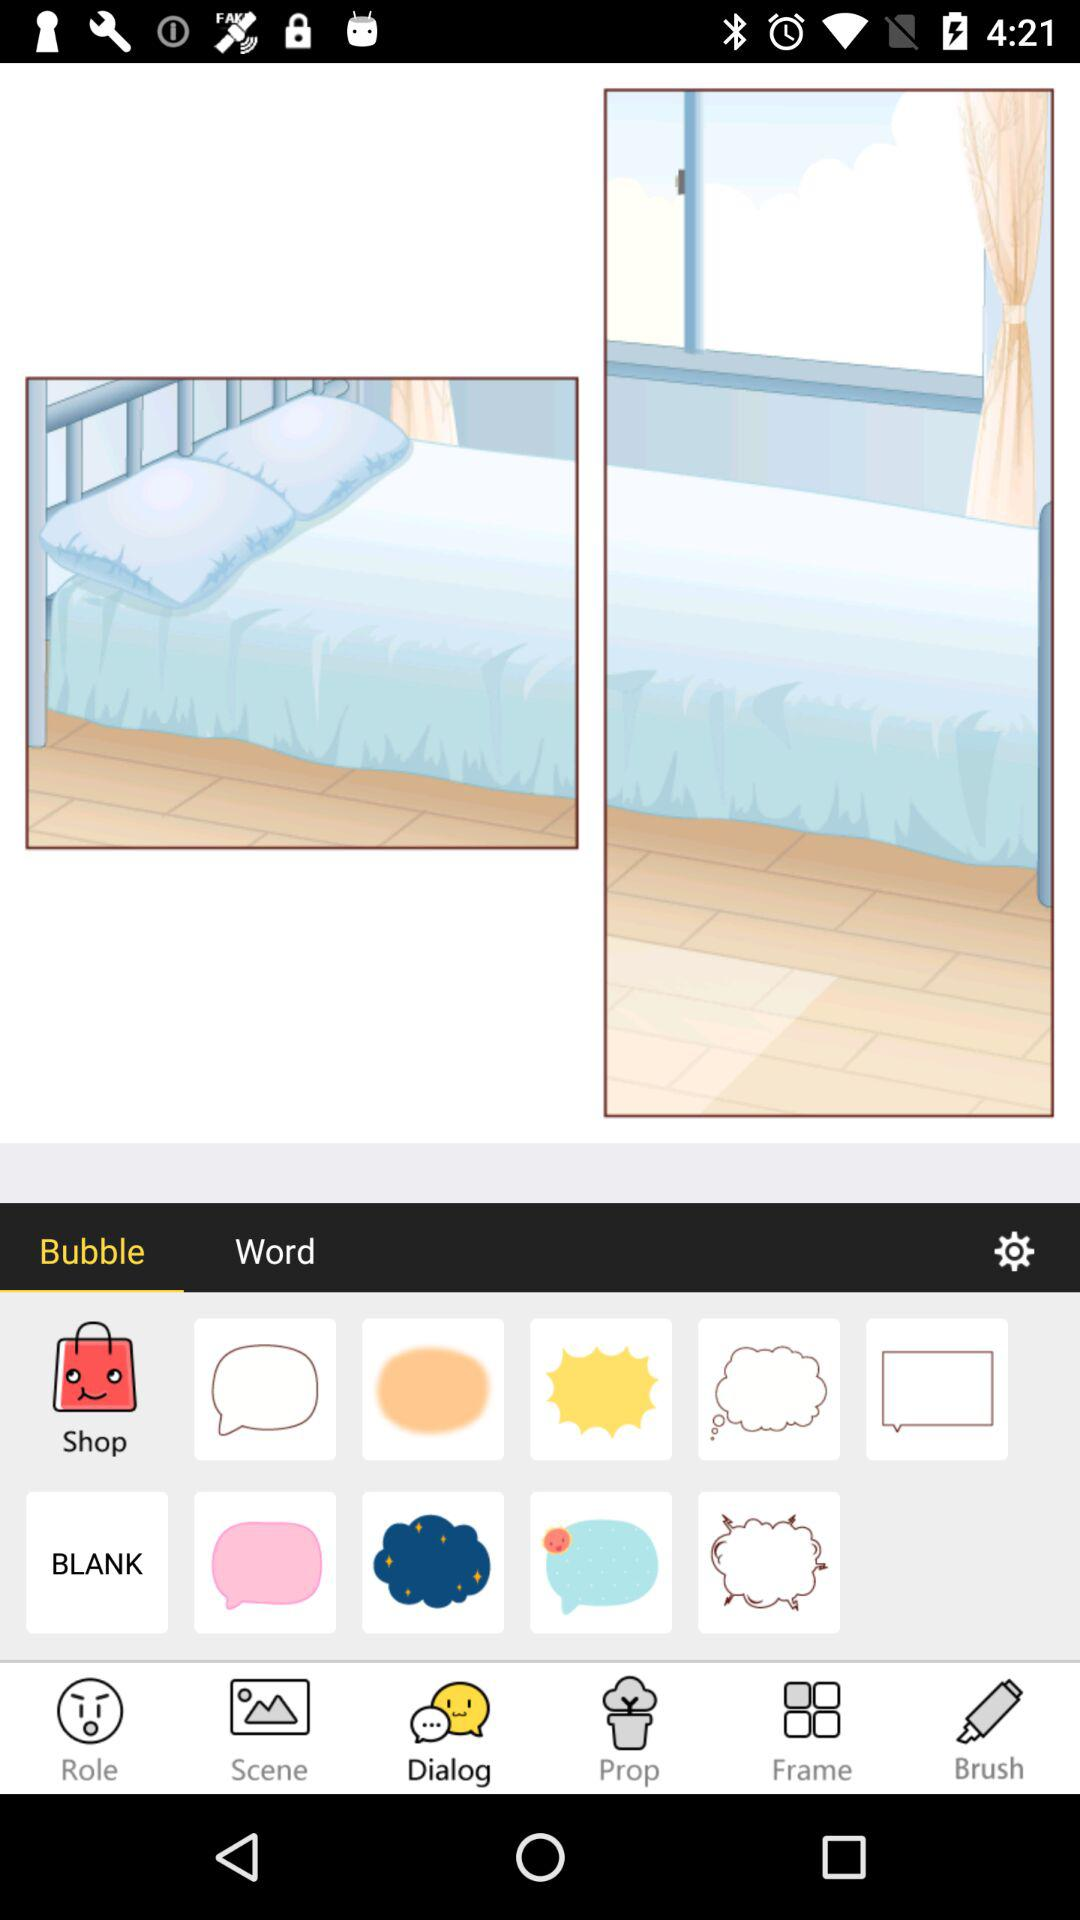Which tab is currently selected in the bottom bar? The currently selected tab in the bottom bar is "Dialog". 